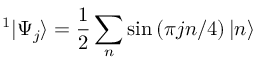Convert formula to latex. <formula><loc_0><loc_0><loc_500><loc_500>^ { 1 } | \Psi _ { j } \rangle = \frac { 1 } { 2 } \sum _ { n } \sin \left ( \pi j n / 4 \right ) | n \rangle</formula> 